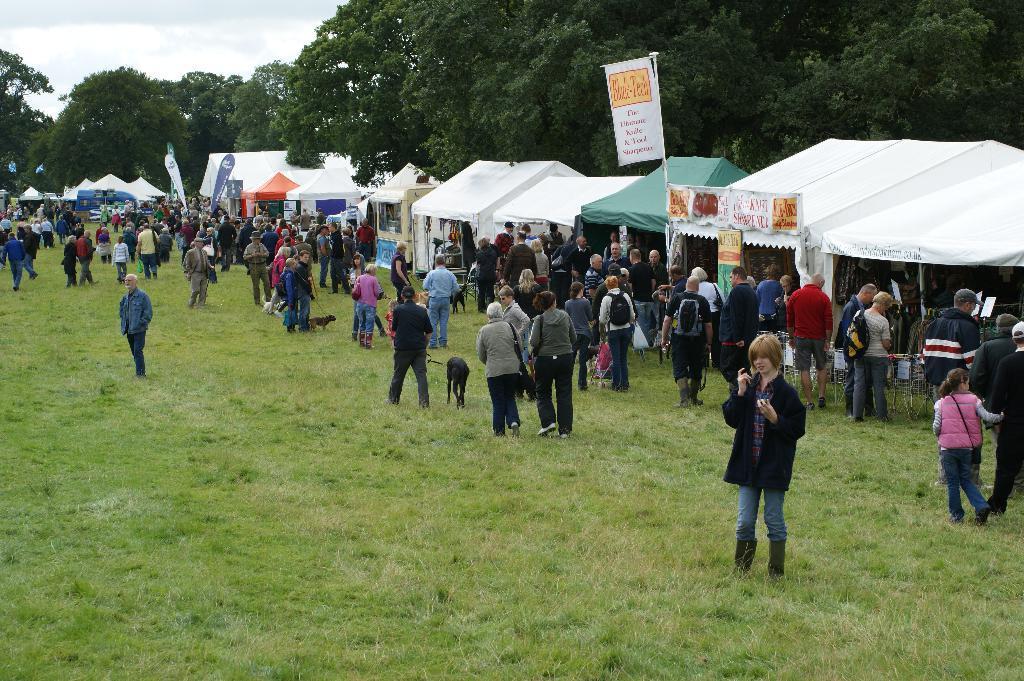Could you give a brief overview of what you see in this image? In this image there are so many people walking on the grass beside them there is a tent and trees. 